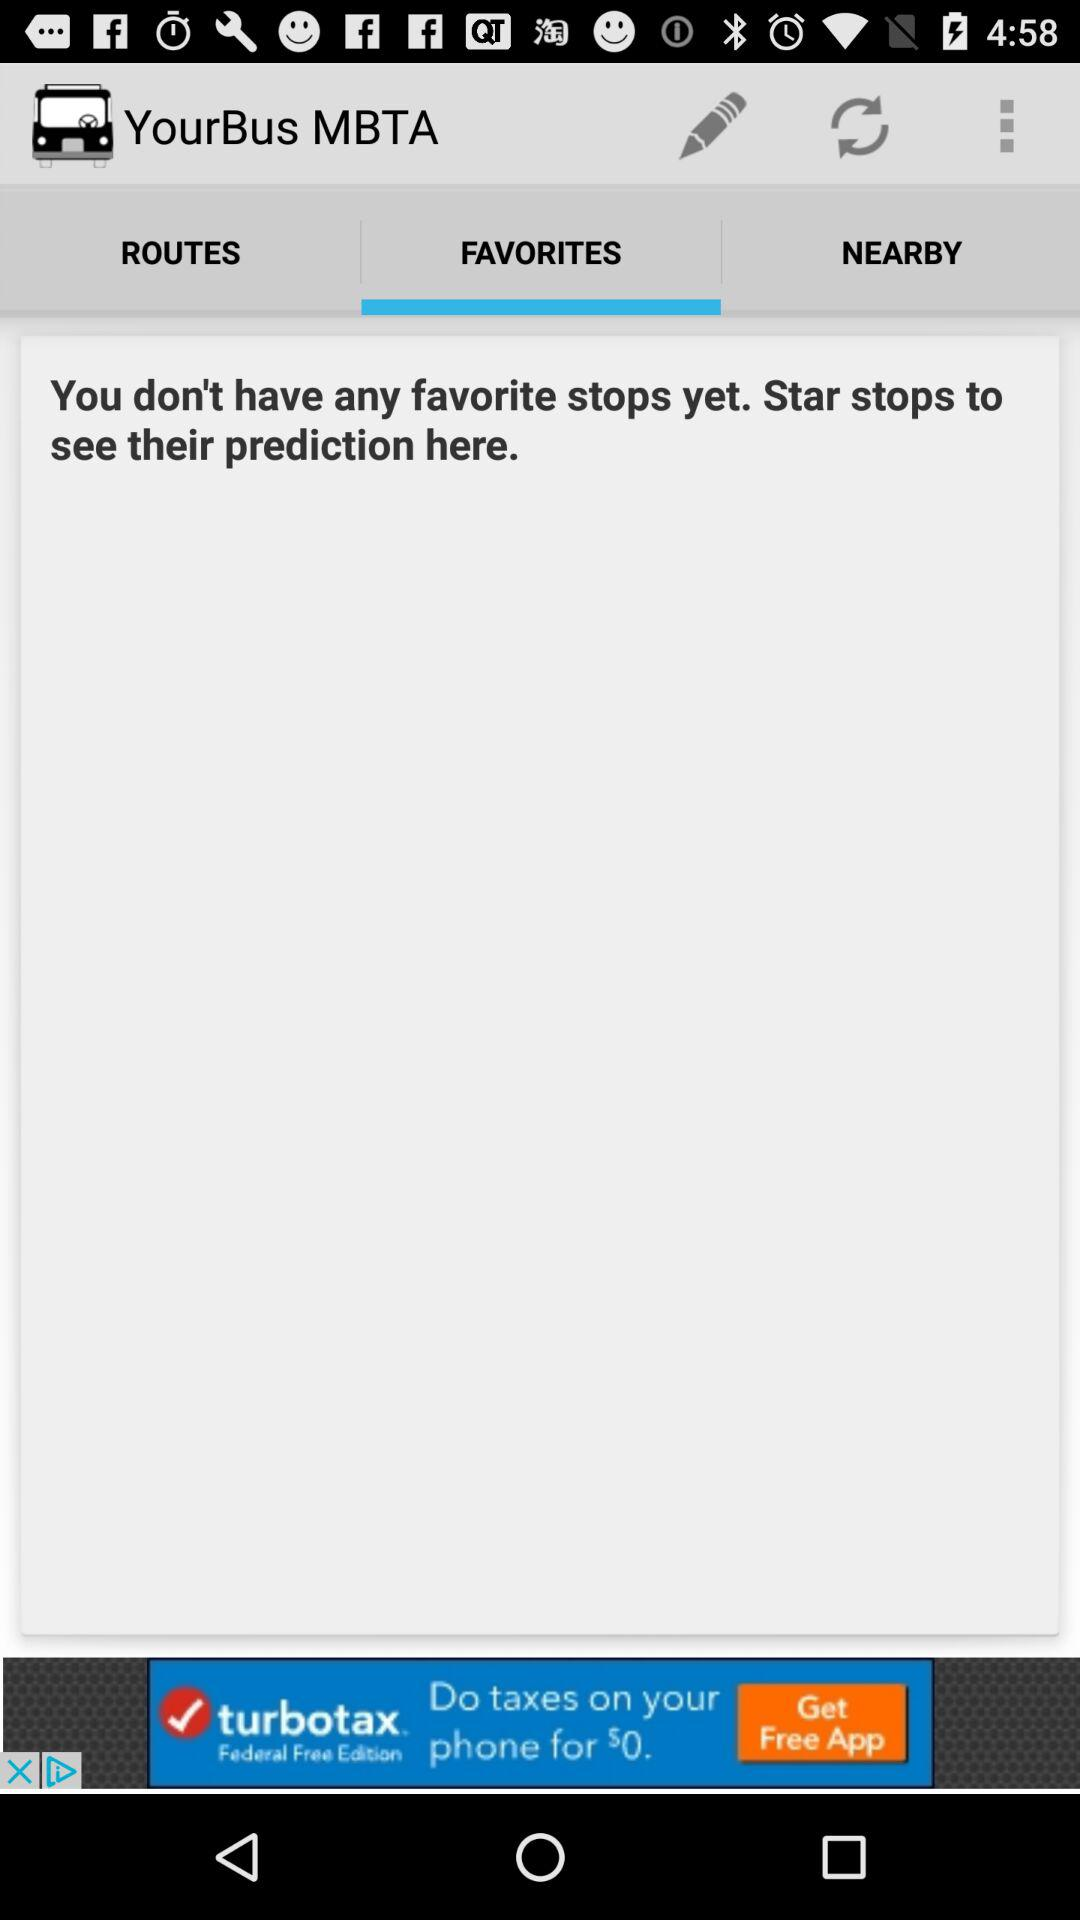What tab has been selected? The selected tab is "FAVORITES". 